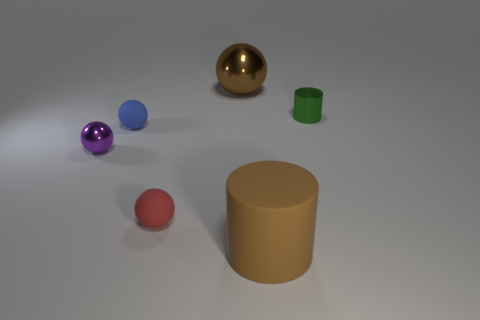Add 2 purple metallic objects. How many objects exist? 8 Subtract all cylinders. How many objects are left? 4 Add 6 small matte balls. How many small matte balls are left? 8 Add 4 large brown matte things. How many large brown matte things exist? 5 Subtract 0 red blocks. How many objects are left? 6 Subtract all small green cylinders. Subtract all small purple metal balls. How many objects are left? 4 